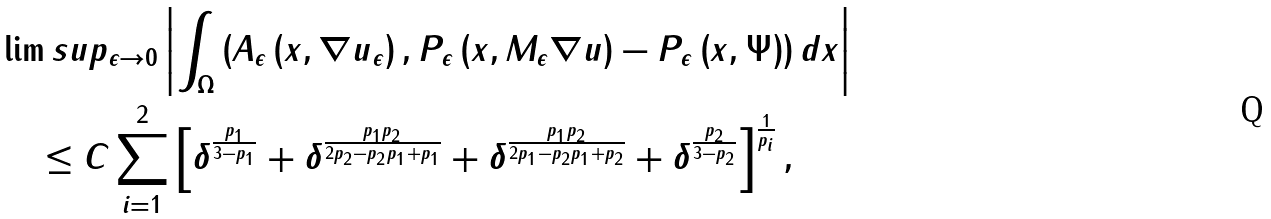<formula> <loc_0><loc_0><loc_500><loc_500>& \lim s u p _ { \epsilon \rightarrow 0 } \left | \int _ { \Omega } \left ( A _ { \epsilon } \left ( x , \nabla u _ { \epsilon } \right ) , P _ { \epsilon } \left ( x , M _ { \epsilon } \nabla u \right ) - P _ { \epsilon } \left ( x , \Psi \right ) \right ) d x \right | \\ & \quad \leq C \sum _ { i = 1 } ^ { 2 } \left [ \delta ^ { \frac { p _ { 1 } } { 3 - p _ { 1 } } } + \delta ^ { \frac { p _ { 1 } p _ { 2 } } { 2 p _ { 2 } - p _ { 2 } p _ { 1 } + p _ { 1 } } } + \delta ^ { \frac { p _ { 1 } p _ { 2 } } { 2 p _ { 1 } - p _ { 2 } p _ { 1 } + p _ { 2 } } } + \delta ^ { \frac { p _ { 2 } } { 3 - p _ { 2 } } } \right ] ^ { \frac { 1 } { p _ { i } } } ,</formula> 